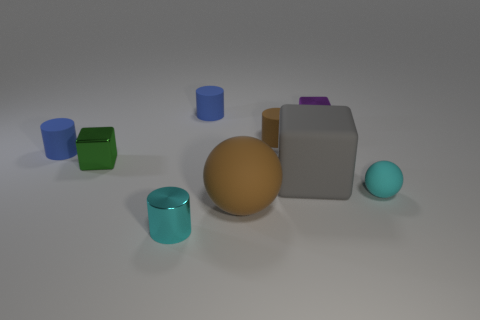There is a tiny sphere that is the same color as the shiny cylinder; what material is it?
Provide a succinct answer. Rubber. Are there fewer gray matte blocks that are to the left of the big cube than large cyan matte things?
Ensure brevity in your answer.  No. Are there any cubes that have the same color as the tiny rubber sphere?
Provide a short and direct response. No. There is a cyan metal thing; does it have the same shape as the matte thing that is behind the brown cylinder?
Keep it short and to the point. Yes. Are there any small blue things made of the same material as the large gray object?
Your answer should be very brief. Yes. Are there any tiny cyan matte things that are behind the big thing to the right of the large brown matte thing that is on the left side of the cyan rubber sphere?
Offer a very short reply. No. What number of other objects are there of the same shape as the small brown matte thing?
Ensure brevity in your answer.  3. What color is the tiny rubber object left of the blue matte cylinder that is to the right of the cylinder that is to the left of the tiny metallic cylinder?
Offer a very short reply. Blue. What number of small balls are there?
Provide a succinct answer. 1. What number of tiny objects are either red shiny spheres or cyan metallic things?
Ensure brevity in your answer.  1. 